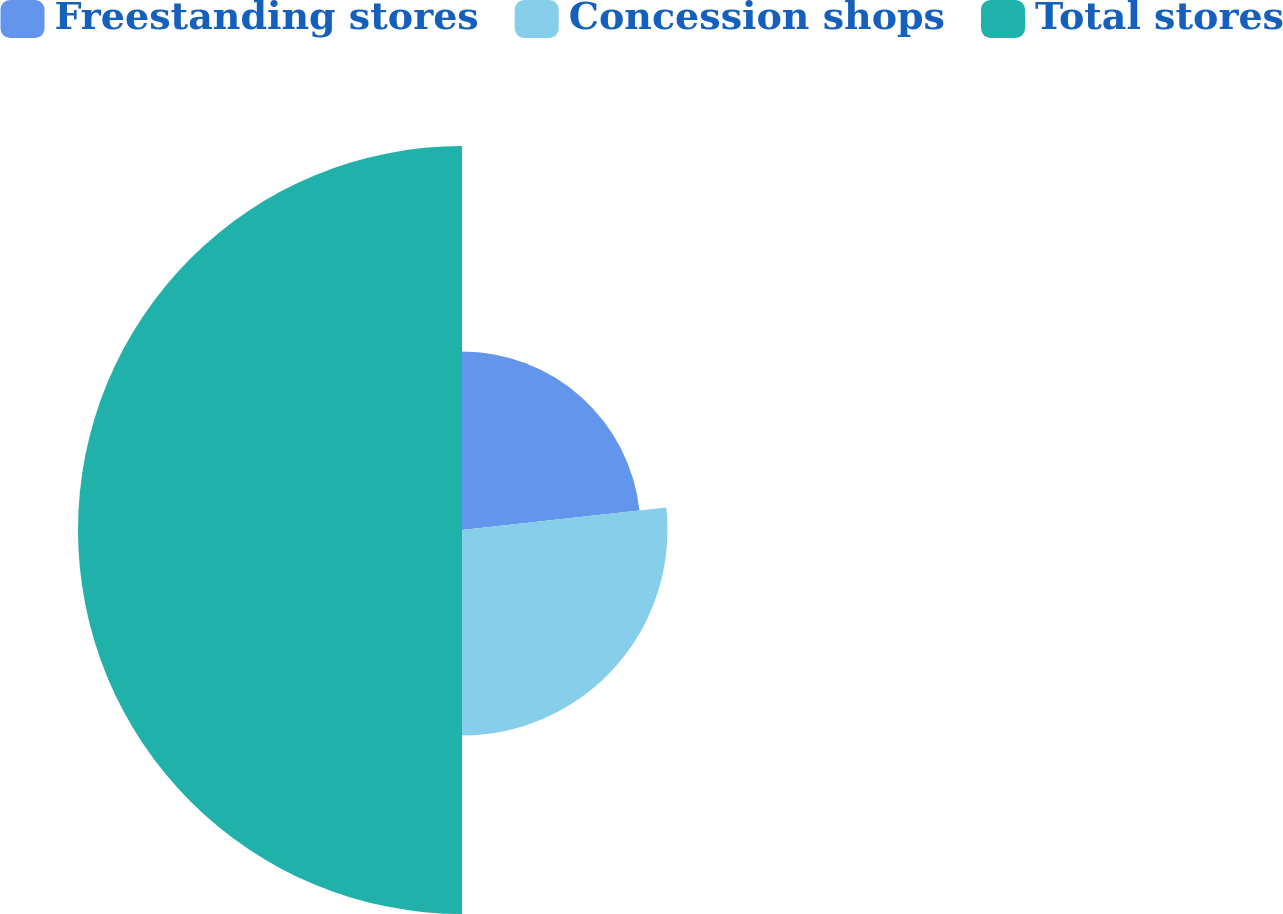Convert chart. <chart><loc_0><loc_0><loc_500><loc_500><pie_chart><fcel>Freestanding stores<fcel>Concession shops<fcel>Total stores<nl><fcel>23.25%<fcel>26.75%<fcel>50.0%<nl></chart> 